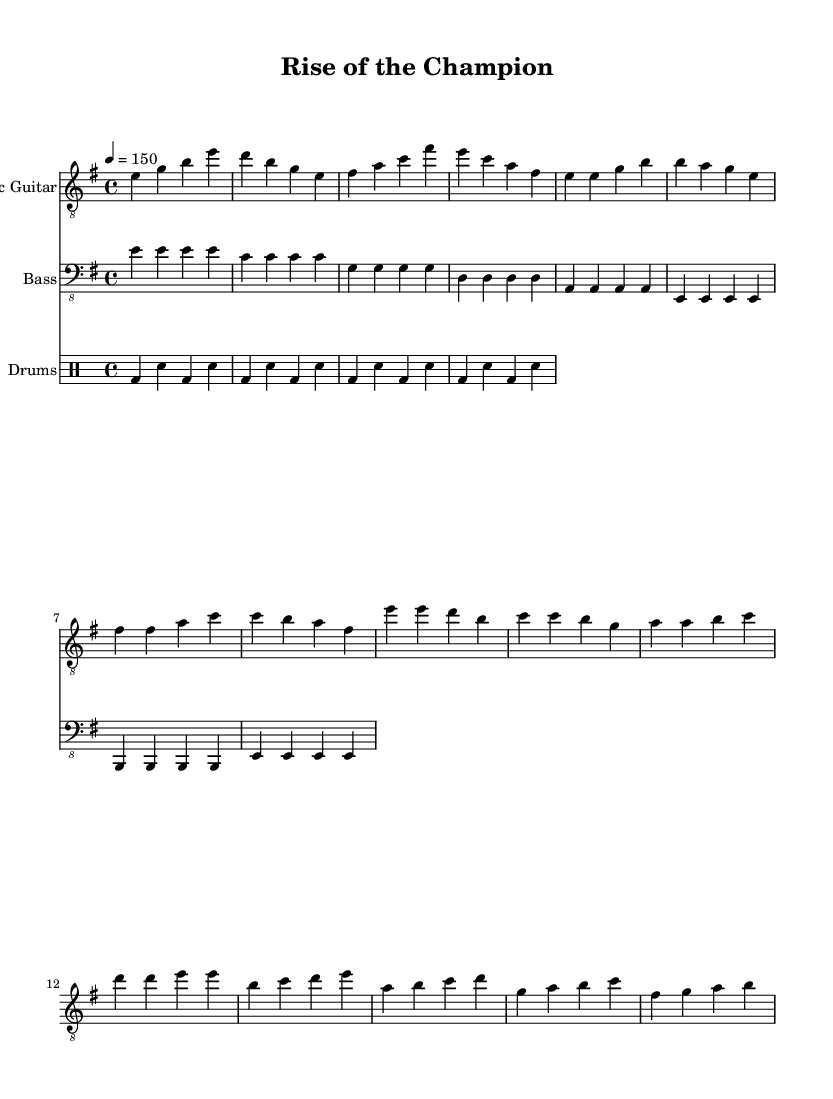What is the key signature of this music? The key signature is indicated at the beginning of the music, showing an E minor key, which contains one sharp (F#).
Answer: E minor What is the time signature of the piece? The time signature is presented alongside the key signature at the start of the piece and it is 4/4, meaning there are four beats per measure.
Answer: 4/4 What is the tempo marking? The tempo marking at the beginning states "4 = 150," indicating the speed of the piece should be 150 beats per minute, reflecting a fast pace.
Answer: 150 How many measures are in the chorus? By counting the sections marked as the chorus in the electric guitar part, there are four distinct measures.
Answer: 4 What is the common rhythmic pattern used in the drums? The drum part features a basic rock beat characterized by a repeated pattern of bass and snare hits that creates a steady pulse.
Answer: Rock beat What is the overall structure of the piece? By analyzing the arrangement as shown in the sheet music, the piece consists of an intro, verse, chorus, and bridge, which are typical for a heavy metal composition.
Answer: Intro, Verse, Chorus, Bridge What guitar clef is used for the electric guitar part? The clef indicated at the beginning of the electric guitar staff is the treble clef, which is standard for high-pitched instruments like the guitar.
Answer: Treble clef 